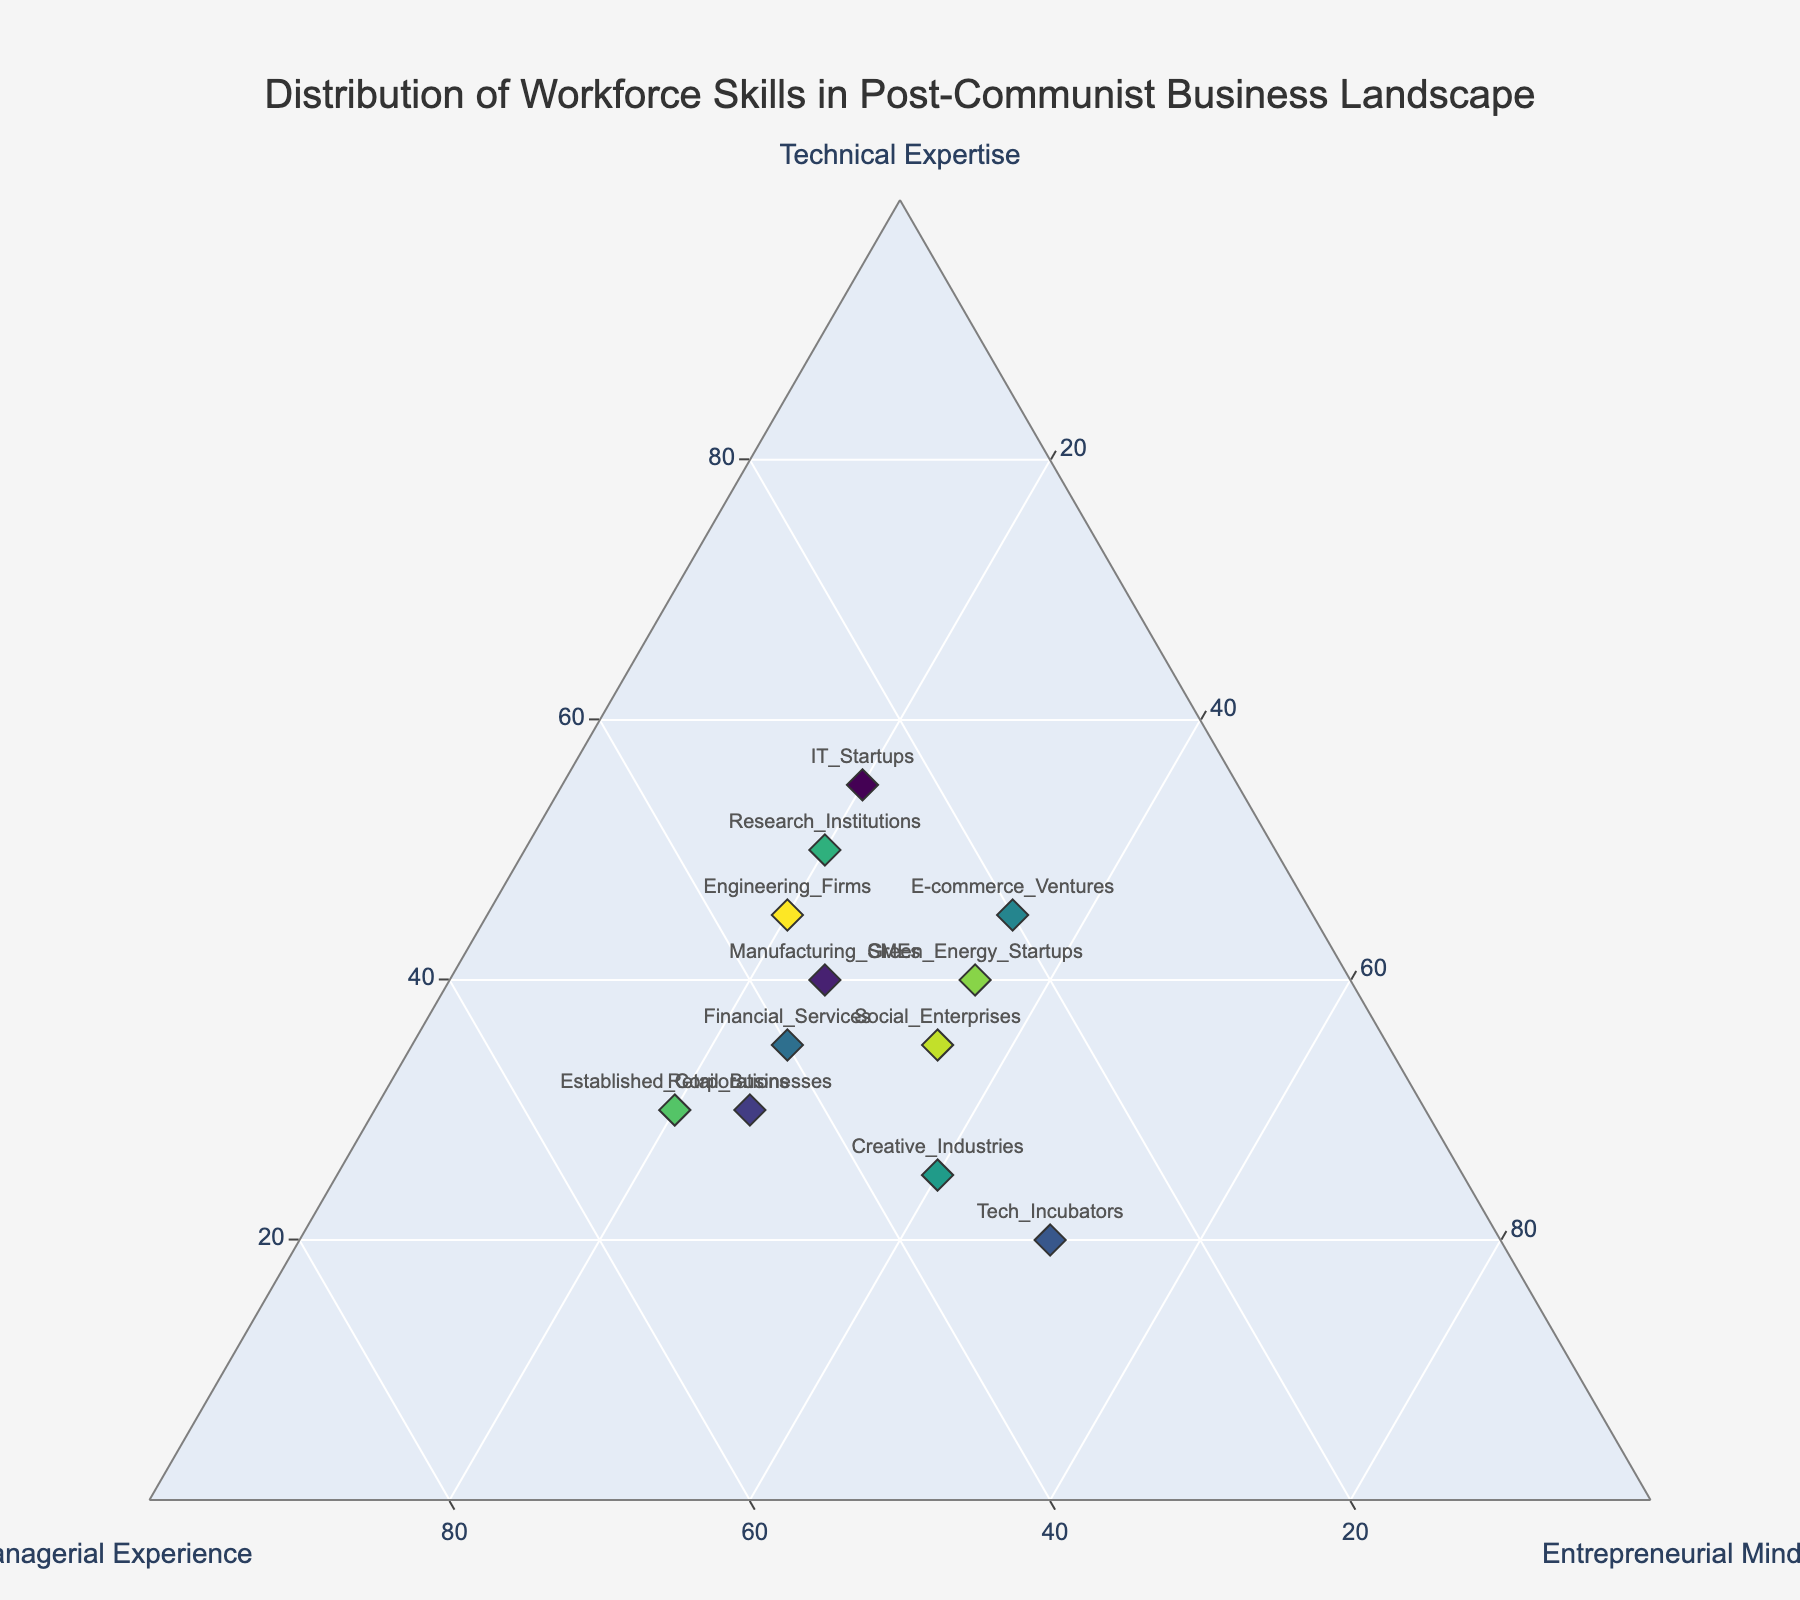What is the total percentage of workforce skills for IT_Startups? We sum up the percentages of Technical Expertise, Managerial Experience, and Entrepreneurial Mindset for IT_Startups: 55% + 25% + 20% = 100%
Answer: 100% Which group has the highest percentage of Entrepreneurial Mindset? By observing the ternary plot, we identify that Tech_Incubators has the highest percentage of Entrepreneurial Mindset at 50%
Answer: Tech_Incubators How many groups have a Managerial Experience percentage of 35%? We count the groups with 35% Managerial Experience: Manufacturing_SMEs, Financial_Services, Creative_Industries, and Engineering_Firms. There are 4 groups in total.
Answer: 4 What are the ranks of IT_Startups and Tech_Incubators in terms of Technical Expertise? IT_Startups has 55% and Tech_Incubators has 20% in Technical Expertise. Therefore, IT_Startups ranks higher than Tech_Incubators in Technical Expertise.
Answer: IT_Startups: Higher, Tech_Incubators: Lower Which group shows a balanced distribution of skills in terms of Technical Expertise, Managerial Experience, and Entrepreneurial Mindset? Social_Enterprises have 35% in both Technical Expertise and Managerial Experience, and 35% in Entrepreneurial Mindset, indicating a balanced distribution.
Answer: Social_Enterprises Compare the Managerial Experience between Retail_Businesses and Established_Corporations. Which one has more? Retail_Businesses has 45% Managerial Experience, whereas Established_Corporations have 50%, so Established_Corporations have more Managerial Experience.
Answer: Established_Corporations Which group is closest to having equal percentages in Technical Expertise, Managerial Experience, and Entrepreneurial Mindset? Social_Enterprises have 35% in all three categories, which is the closest to equal distribution.
Answer: Social_Enterprises Out of the groups with at least 40% Technical Expertise, which group has the highest percentage of Entrepreneurial Mindset? We compare the groups with at least 40% Technical Expertise (IT_Startups, Research_Institutions, E-commerce_Ventures, Engineering_Firms). E-commerce_Ventures has the highest Entrepreneurial Mindset at 35%.
Answer: E-commerce_Ventures 